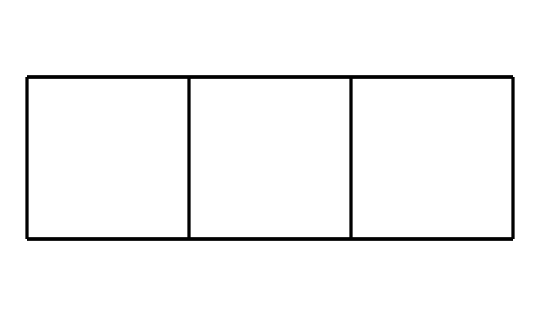What is the name of this compound? The SMILES representation corresponds to a cubic hydrocarbon structure, known as Cubane, characterized by its carbon and hydrogen atoms arranged in a cube shape.
Answer: Cubane How many carbon atoms are present in the structure? By analyzing the SMILES string, the number of unique carbon symbols (C) in the formula can be counted; in this case, there are 8 carbon atoms.
Answer: 8 What is the total number of hydrogen atoms in Cubane? Each carbon atom in Cubane is bonded to two other carbon atoms and to hydrogen atoms to satisfy carbon's tetravalency. Each of the 8 carbon atoms bonds with 2 hydrogen atoms, resulting in a total of 16 hydrogen atoms (8 C x (4-2)=16 H).
Answer: 16 How many total bonds are formed in the Cubane structure? In Cubane, each of the 8 carbon atoms forms 4 bonds (2 with other carbons and 2 with hydrogens). Therefore, the total number of bonds is calculated as 8 C x 4 = 32. However, each bond is counted twice in this context, so the total number of unique bonds is half of that, which is 16.
Answer: 32 What specific cage shape does this compound exhibit? The unique arrangement of carbon atoms in Cubane forms a three-dimensional cube shape, distinct to cage compounds, where the molecular geometry corresponds to a square planar arrangement.
Answer: Cube Is this compound considered a saturated hydrocarbon? A saturated hydrocarbon is defined as a compound that contains only single bonds between carbon atoms. Since the structure exhibits only single bonds, it meets this definition.
Answer: Yes 